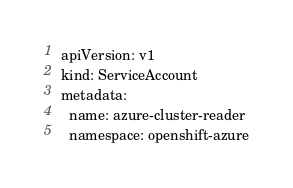<code> <loc_0><loc_0><loc_500><loc_500><_YAML_>apiVersion: v1
kind: ServiceAccount
metadata:
  name: azure-cluster-reader
  namespace: openshift-azure
</code> 